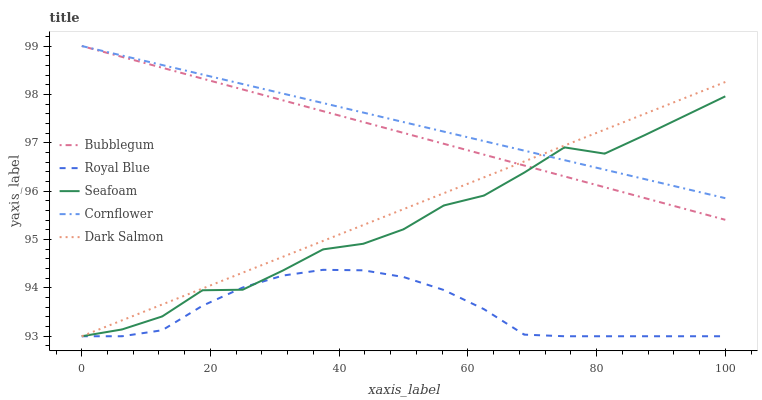Does Royal Blue have the minimum area under the curve?
Answer yes or no. Yes. Does Cornflower have the maximum area under the curve?
Answer yes or no. Yes. Does Dark Salmon have the minimum area under the curve?
Answer yes or no. No. Does Dark Salmon have the maximum area under the curve?
Answer yes or no. No. Is Dark Salmon the smoothest?
Answer yes or no. Yes. Is Seafoam the roughest?
Answer yes or no. Yes. Is Seafoam the smoothest?
Answer yes or no. No. Is Dark Salmon the roughest?
Answer yes or no. No. Does Royal Blue have the lowest value?
Answer yes or no. Yes. Does Bubblegum have the lowest value?
Answer yes or no. No. Does Cornflower have the highest value?
Answer yes or no. Yes. Does Dark Salmon have the highest value?
Answer yes or no. No. Is Royal Blue less than Cornflower?
Answer yes or no. Yes. Is Bubblegum greater than Royal Blue?
Answer yes or no. Yes. Does Royal Blue intersect Seafoam?
Answer yes or no. Yes. Is Royal Blue less than Seafoam?
Answer yes or no. No. Is Royal Blue greater than Seafoam?
Answer yes or no. No. Does Royal Blue intersect Cornflower?
Answer yes or no. No. 